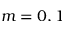<formula> <loc_0><loc_0><loc_500><loc_500>m = 0 , 1</formula> 